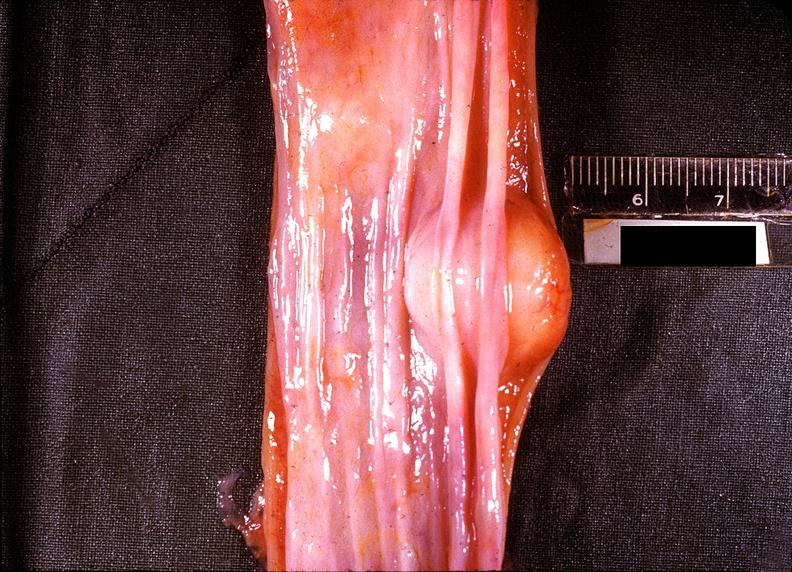s marfans syndrome present?
Answer the question using a single word or phrase. No 